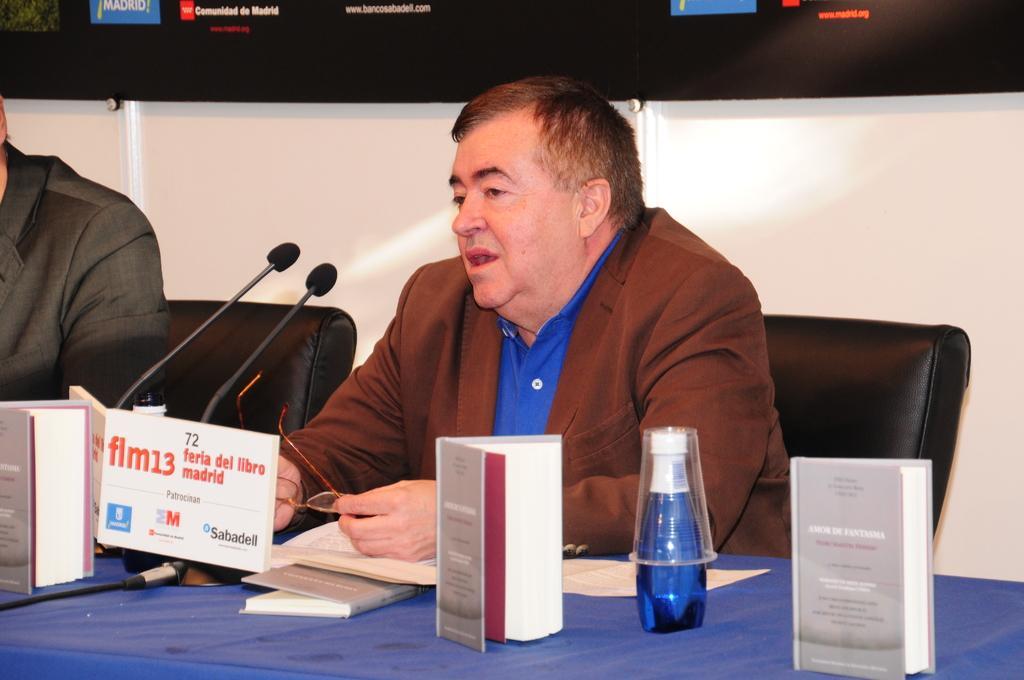How would you summarize this image in a sentence or two? In this image we can see two persons sitting on chairs. There is a table. On the table there are books, bottles, glass and mics. And the person is holding a specs. In the back there is a blackboard. 